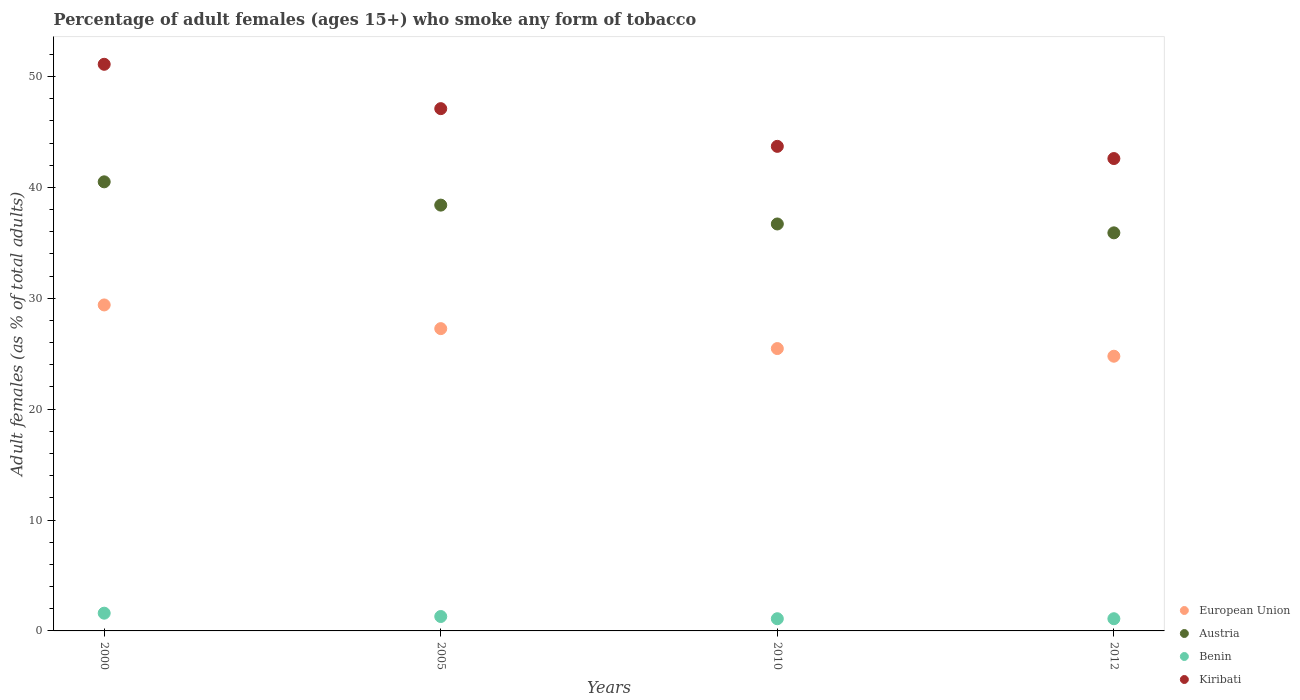How many different coloured dotlines are there?
Give a very brief answer. 4. What is the percentage of adult females who smoke in Austria in 2005?
Your answer should be very brief. 38.4. Across all years, what is the maximum percentage of adult females who smoke in Kiribati?
Your answer should be very brief. 51.1. Across all years, what is the minimum percentage of adult females who smoke in European Union?
Your answer should be very brief. 24.77. In which year was the percentage of adult females who smoke in European Union minimum?
Give a very brief answer. 2012. What is the difference between the percentage of adult females who smoke in Kiribati in 2005 and that in 2010?
Your response must be concise. 3.4. What is the difference between the percentage of adult females who smoke in Kiribati in 2012 and the percentage of adult females who smoke in Austria in 2010?
Your response must be concise. 5.9. What is the average percentage of adult females who smoke in Austria per year?
Make the answer very short. 37.88. In the year 2005, what is the difference between the percentage of adult females who smoke in European Union and percentage of adult females who smoke in Kiribati?
Make the answer very short. -19.84. In how many years, is the percentage of adult females who smoke in European Union greater than 38 %?
Your answer should be very brief. 0. What is the ratio of the percentage of adult females who smoke in Kiribati in 2000 to that in 2005?
Keep it short and to the point. 1.08. Is the difference between the percentage of adult females who smoke in European Union in 2000 and 2005 greater than the difference between the percentage of adult females who smoke in Kiribati in 2000 and 2005?
Offer a very short reply. No. What is the difference between the highest and the second highest percentage of adult females who smoke in European Union?
Your answer should be very brief. 2.14. What is the difference between the highest and the lowest percentage of adult females who smoke in Kiribati?
Keep it short and to the point. 8.5. In how many years, is the percentage of adult females who smoke in Austria greater than the average percentage of adult females who smoke in Austria taken over all years?
Make the answer very short. 2. Is the sum of the percentage of adult females who smoke in Kiribati in 2005 and 2010 greater than the maximum percentage of adult females who smoke in European Union across all years?
Keep it short and to the point. Yes. Is it the case that in every year, the sum of the percentage of adult females who smoke in Kiribati and percentage of adult females who smoke in Austria  is greater than the sum of percentage of adult females who smoke in Benin and percentage of adult females who smoke in European Union?
Your answer should be compact. No. Does the percentage of adult females who smoke in Benin monotonically increase over the years?
Keep it short and to the point. No. Is the percentage of adult females who smoke in Benin strictly greater than the percentage of adult females who smoke in Kiribati over the years?
Give a very brief answer. No. Is the percentage of adult females who smoke in Austria strictly less than the percentage of adult females who smoke in Benin over the years?
Keep it short and to the point. No. How many years are there in the graph?
Offer a very short reply. 4. Are the values on the major ticks of Y-axis written in scientific E-notation?
Ensure brevity in your answer.  No. Does the graph contain any zero values?
Your answer should be compact. No. Where does the legend appear in the graph?
Your answer should be compact. Bottom right. How many legend labels are there?
Provide a succinct answer. 4. What is the title of the graph?
Offer a very short reply. Percentage of adult females (ages 15+) who smoke any form of tobacco. What is the label or title of the Y-axis?
Offer a very short reply. Adult females (as % of total adults). What is the Adult females (as % of total adults) of European Union in 2000?
Your answer should be very brief. 29.4. What is the Adult females (as % of total adults) of Austria in 2000?
Provide a short and direct response. 40.5. What is the Adult females (as % of total adults) in Kiribati in 2000?
Your answer should be very brief. 51.1. What is the Adult females (as % of total adults) in European Union in 2005?
Your answer should be compact. 27.26. What is the Adult females (as % of total adults) of Austria in 2005?
Your answer should be very brief. 38.4. What is the Adult females (as % of total adults) of Benin in 2005?
Offer a terse response. 1.3. What is the Adult females (as % of total adults) in Kiribati in 2005?
Your response must be concise. 47.1. What is the Adult females (as % of total adults) in European Union in 2010?
Keep it short and to the point. 25.46. What is the Adult females (as % of total adults) in Austria in 2010?
Offer a terse response. 36.7. What is the Adult females (as % of total adults) in Benin in 2010?
Keep it short and to the point. 1.1. What is the Adult females (as % of total adults) of Kiribati in 2010?
Your response must be concise. 43.7. What is the Adult females (as % of total adults) in European Union in 2012?
Provide a short and direct response. 24.77. What is the Adult females (as % of total adults) of Austria in 2012?
Provide a short and direct response. 35.9. What is the Adult females (as % of total adults) of Benin in 2012?
Give a very brief answer. 1.1. What is the Adult females (as % of total adults) in Kiribati in 2012?
Provide a succinct answer. 42.6. Across all years, what is the maximum Adult females (as % of total adults) of European Union?
Offer a terse response. 29.4. Across all years, what is the maximum Adult females (as % of total adults) in Austria?
Offer a very short reply. 40.5. Across all years, what is the maximum Adult females (as % of total adults) in Kiribati?
Your answer should be very brief. 51.1. Across all years, what is the minimum Adult females (as % of total adults) in European Union?
Keep it short and to the point. 24.77. Across all years, what is the minimum Adult females (as % of total adults) of Austria?
Offer a very short reply. 35.9. Across all years, what is the minimum Adult females (as % of total adults) of Benin?
Keep it short and to the point. 1.1. Across all years, what is the minimum Adult females (as % of total adults) in Kiribati?
Your answer should be very brief. 42.6. What is the total Adult females (as % of total adults) of European Union in the graph?
Offer a terse response. 106.9. What is the total Adult females (as % of total adults) of Austria in the graph?
Your answer should be compact. 151.5. What is the total Adult females (as % of total adults) of Kiribati in the graph?
Offer a very short reply. 184.5. What is the difference between the Adult females (as % of total adults) of European Union in 2000 and that in 2005?
Give a very brief answer. 2.14. What is the difference between the Adult females (as % of total adults) of Austria in 2000 and that in 2005?
Offer a very short reply. 2.1. What is the difference between the Adult females (as % of total adults) of European Union in 2000 and that in 2010?
Offer a terse response. 3.93. What is the difference between the Adult females (as % of total adults) of Benin in 2000 and that in 2010?
Provide a short and direct response. 0.5. What is the difference between the Adult females (as % of total adults) of European Union in 2000 and that in 2012?
Offer a very short reply. 4.62. What is the difference between the Adult females (as % of total adults) of Austria in 2000 and that in 2012?
Your answer should be compact. 4.6. What is the difference between the Adult females (as % of total adults) of Benin in 2000 and that in 2012?
Your answer should be compact. 0.5. What is the difference between the Adult females (as % of total adults) in Kiribati in 2000 and that in 2012?
Keep it short and to the point. 8.5. What is the difference between the Adult females (as % of total adults) of European Union in 2005 and that in 2010?
Ensure brevity in your answer.  1.8. What is the difference between the Adult females (as % of total adults) of Kiribati in 2005 and that in 2010?
Your answer should be compact. 3.4. What is the difference between the Adult females (as % of total adults) of European Union in 2005 and that in 2012?
Offer a very short reply. 2.49. What is the difference between the Adult females (as % of total adults) in Austria in 2005 and that in 2012?
Make the answer very short. 2.5. What is the difference between the Adult females (as % of total adults) of Kiribati in 2005 and that in 2012?
Your response must be concise. 4.5. What is the difference between the Adult females (as % of total adults) of European Union in 2010 and that in 2012?
Give a very brief answer. 0.69. What is the difference between the Adult females (as % of total adults) of Austria in 2010 and that in 2012?
Offer a terse response. 0.8. What is the difference between the Adult females (as % of total adults) of Benin in 2010 and that in 2012?
Offer a very short reply. 0. What is the difference between the Adult females (as % of total adults) in European Union in 2000 and the Adult females (as % of total adults) in Austria in 2005?
Provide a succinct answer. -9. What is the difference between the Adult females (as % of total adults) of European Union in 2000 and the Adult females (as % of total adults) of Benin in 2005?
Offer a terse response. 28.1. What is the difference between the Adult females (as % of total adults) in European Union in 2000 and the Adult females (as % of total adults) in Kiribati in 2005?
Provide a short and direct response. -17.7. What is the difference between the Adult females (as % of total adults) in Austria in 2000 and the Adult females (as % of total adults) in Benin in 2005?
Provide a succinct answer. 39.2. What is the difference between the Adult females (as % of total adults) in Austria in 2000 and the Adult females (as % of total adults) in Kiribati in 2005?
Provide a succinct answer. -6.6. What is the difference between the Adult females (as % of total adults) of Benin in 2000 and the Adult females (as % of total adults) of Kiribati in 2005?
Offer a very short reply. -45.5. What is the difference between the Adult females (as % of total adults) in European Union in 2000 and the Adult females (as % of total adults) in Austria in 2010?
Offer a very short reply. -7.3. What is the difference between the Adult females (as % of total adults) in European Union in 2000 and the Adult females (as % of total adults) in Benin in 2010?
Your answer should be compact. 28.3. What is the difference between the Adult females (as % of total adults) in European Union in 2000 and the Adult females (as % of total adults) in Kiribati in 2010?
Offer a very short reply. -14.3. What is the difference between the Adult females (as % of total adults) in Austria in 2000 and the Adult females (as % of total adults) in Benin in 2010?
Your answer should be compact. 39.4. What is the difference between the Adult females (as % of total adults) in Austria in 2000 and the Adult females (as % of total adults) in Kiribati in 2010?
Ensure brevity in your answer.  -3.2. What is the difference between the Adult females (as % of total adults) in Benin in 2000 and the Adult females (as % of total adults) in Kiribati in 2010?
Offer a terse response. -42.1. What is the difference between the Adult females (as % of total adults) of European Union in 2000 and the Adult females (as % of total adults) of Austria in 2012?
Ensure brevity in your answer.  -6.5. What is the difference between the Adult females (as % of total adults) in European Union in 2000 and the Adult females (as % of total adults) in Benin in 2012?
Provide a succinct answer. 28.3. What is the difference between the Adult females (as % of total adults) of European Union in 2000 and the Adult females (as % of total adults) of Kiribati in 2012?
Your response must be concise. -13.2. What is the difference between the Adult females (as % of total adults) of Austria in 2000 and the Adult females (as % of total adults) of Benin in 2012?
Keep it short and to the point. 39.4. What is the difference between the Adult females (as % of total adults) in Austria in 2000 and the Adult females (as % of total adults) in Kiribati in 2012?
Your answer should be very brief. -2.1. What is the difference between the Adult females (as % of total adults) of Benin in 2000 and the Adult females (as % of total adults) of Kiribati in 2012?
Your answer should be very brief. -41. What is the difference between the Adult females (as % of total adults) of European Union in 2005 and the Adult females (as % of total adults) of Austria in 2010?
Ensure brevity in your answer.  -9.44. What is the difference between the Adult females (as % of total adults) of European Union in 2005 and the Adult females (as % of total adults) of Benin in 2010?
Your answer should be very brief. 26.16. What is the difference between the Adult females (as % of total adults) of European Union in 2005 and the Adult females (as % of total adults) of Kiribati in 2010?
Offer a terse response. -16.44. What is the difference between the Adult females (as % of total adults) in Austria in 2005 and the Adult females (as % of total adults) in Benin in 2010?
Provide a short and direct response. 37.3. What is the difference between the Adult females (as % of total adults) of Benin in 2005 and the Adult females (as % of total adults) of Kiribati in 2010?
Ensure brevity in your answer.  -42.4. What is the difference between the Adult females (as % of total adults) of European Union in 2005 and the Adult females (as % of total adults) of Austria in 2012?
Provide a short and direct response. -8.64. What is the difference between the Adult females (as % of total adults) in European Union in 2005 and the Adult females (as % of total adults) in Benin in 2012?
Ensure brevity in your answer.  26.16. What is the difference between the Adult females (as % of total adults) of European Union in 2005 and the Adult females (as % of total adults) of Kiribati in 2012?
Provide a short and direct response. -15.34. What is the difference between the Adult females (as % of total adults) of Austria in 2005 and the Adult females (as % of total adults) of Benin in 2012?
Your answer should be very brief. 37.3. What is the difference between the Adult females (as % of total adults) in Benin in 2005 and the Adult females (as % of total adults) in Kiribati in 2012?
Give a very brief answer. -41.3. What is the difference between the Adult females (as % of total adults) in European Union in 2010 and the Adult females (as % of total adults) in Austria in 2012?
Ensure brevity in your answer.  -10.44. What is the difference between the Adult females (as % of total adults) in European Union in 2010 and the Adult females (as % of total adults) in Benin in 2012?
Provide a short and direct response. 24.36. What is the difference between the Adult females (as % of total adults) of European Union in 2010 and the Adult females (as % of total adults) of Kiribati in 2012?
Provide a succinct answer. -17.14. What is the difference between the Adult females (as % of total adults) in Austria in 2010 and the Adult females (as % of total adults) in Benin in 2012?
Your response must be concise. 35.6. What is the difference between the Adult females (as % of total adults) in Austria in 2010 and the Adult females (as % of total adults) in Kiribati in 2012?
Provide a short and direct response. -5.9. What is the difference between the Adult females (as % of total adults) in Benin in 2010 and the Adult females (as % of total adults) in Kiribati in 2012?
Your answer should be compact. -41.5. What is the average Adult females (as % of total adults) of European Union per year?
Your answer should be very brief. 26.72. What is the average Adult females (as % of total adults) in Austria per year?
Offer a terse response. 37.88. What is the average Adult females (as % of total adults) in Benin per year?
Ensure brevity in your answer.  1.27. What is the average Adult females (as % of total adults) in Kiribati per year?
Keep it short and to the point. 46.12. In the year 2000, what is the difference between the Adult females (as % of total adults) in European Union and Adult females (as % of total adults) in Austria?
Make the answer very short. -11.1. In the year 2000, what is the difference between the Adult females (as % of total adults) in European Union and Adult females (as % of total adults) in Benin?
Offer a terse response. 27.8. In the year 2000, what is the difference between the Adult females (as % of total adults) of European Union and Adult females (as % of total adults) of Kiribati?
Your answer should be very brief. -21.7. In the year 2000, what is the difference between the Adult females (as % of total adults) in Austria and Adult females (as % of total adults) in Benin?
Your response must be concise. 38.9. In the year 2000, what is the difference between the Adult females (as % of total adults) in Austria and Adult females (as % of total adults) in Kiribati?
Your response must be concise. -10.6. In the year 2000, what is the difference between the Adult females (as % of total adults) in Benin and Adult females (as % of total adults) in Kiribati?
Your answer should be compact. -49.5. In the year 2005, what is the difference between the Adult females (as % of total adults) of European Union and Adult females (as % of total adults) of Austria?
Ensure brevity in your answer.  -11.14. In the year 2005, what is the difference between the Adult females (as % of total adults) in European Union and Adult females (as % of total adults) in Benin?
Your answer should be compact. 25.96. In the year 2005, what is the difference between the Adult females (as % of total adults) of European Union and Adult females (as % of total adults) of Kiribati?
Offer a very short reply. -19.84. In the year 2005, what is the difference between the Adult females (as % of total adults) in Austria and Adult females (as % of total adults) in Benin?
Your response must be concise. 37.1. In the year 2005, what is the difference between the Adult females (as % of total adults) in Austria and Adult females (as % of total adults) in Kiribati?
Your response must be concise. -8.7. In the year 2005, what is the difference between the Adult females (as % of total adults) in Benin and Adult females (as % of total adults) in Kiribati?
Ensure brevity in your answer.  -45.8. In the year 2010, what is the difference between the Adult females (as % of total adults) of European Union and Adult females (as % of total adults) of Austria?
Offer a terse response. -11.24. In the year 2010, what is the difference between the Adult females (as % of total adults) of European Union and Adult females (as % of total adults) of Benin?
Give a very brief answer. 24.36. In the year 2010, what is the difference between the Adult females (as % of total adults) of European Union and Adult females (as % of total adults) of Kiribati?
Provide a succinct answer. -18.24. In the year 2010, what is the difference between the Adult females (as % of total adults) in Austria and Adult females (as % of total adults) in Benin?
Make the answer very short. 35.6. In the year 2010, what is the difference between the Adult females (as % of total adults) of Austria and Adult females (as % of total adults) of Kiribati?
Keep it short and to the point. -7. In the year 2010, what is the difference between the Adult females (as % of total adults) in Benin and Adult females (as % of total adults) in Kiribati?
Provide a succinct answer. -42.6. In the year 2012, what is the difference between the Adult females (as % of total adults) in European Union and Adult females (as % of total adults) in Austria?
Your answer should be compact. -11.13. In the year 2012, what is the difference between the Adult females (as % of total adults) of European Union and Adult females (as % of total adults) of Benin?
Your answer should be very brief. 23.67. In the year 2012, what is the difference between the Adult females (as % of total adults) of European Union and Adult females (as % of total adults) of Kiribati?
Your answer should be very brief. -17.83. In the year 2012, what is the difference between the Adult females (as % of total adults) of Austria and Adult females (as % of total adults) of Benin?
Offer a terse response. 34.8. In the year 2012, what is the difference between the Adult females (as % of total adults) of Austria and Adult females (as % of total adults) of Kiribati?
Ensure brevity in your answer.  -6.7. In the year 2012, what is the difference between the Adult females (as % of total adults) of Benin and Adult females (as % of total adults) of Kiribati?
Offer a very short reply. -41.5. What is the ratio of the Adult females (as % of total adults) in European Union in 2000 to that in 2005?
Offer a terse response. 1.08. What is the ratio of the Adult females (as % of total adults) of Austria in 2000 to that in 2005?
Give a very brief answer. 1.05. What is the ratio of the Adult females (as % of total adults) of Benin in 2000 to that in 2005?
Give a very brief answer. 1.23. What is the ratio of the Adult females (as % of total adults) in Kiribati in 2000 to that in 2005?
Your answer should be compact. 1.08. What is the ratio of the Adult females (as % of total adults) of European Union in 2000 to that in 2010?
Provide a short and direct response. 1.15. What is the ratio of the Adult females (as % of total adults) of Austria in 2000 to that in 2010?
Your answer should be compact. 1.1. What is the ratio of the Adult females (as % of total adults) of Benin in 2000 to that in 2010?
Your answer should be compact. 1.45. What is the ratio of the Adult females (as % of total adults) in Kiribati in 2000 to that in 2010?
Provide a short and direct response. 1.17. What is the ratio of the Adult females (as % of total adults) of European Union in 2000 to that in 2012?
Offer a very short reply. 1.19. What is the ratio of the Adult females (as % of total adults) of Austria in 2000 to that in 2012?
Your answer should be very brief. 1.13. What is the ratio of the Adult females (as % of total adults) in Benin in 2000 to that in 2012?
Your answer should be very brief. 1.45. What is the ratio of the Adult females (as % of total adults) of Kiribati in 2000 to that in 2012?
Keep it short and to the point. 1.2. What is the ratio of the Adult females (as % of total adults) of European Union in 2005 to that in 2010?
Provide a succinct answer. 1.07. What is the ratio of the Adult females (as % of total adults) in Austria in 2005 to that in 2010?
Make the answer very short. 1.05. What is the ratio of the Adult females (as % of total adults) in Benin in 2005 to that in 2010?
Provide a short and direct response. 1.18. What is the ratio of the Adult females (as % of total adults) of Kiribati in 2005 to that in 2010?
Your response must be concise. 1.08. What is the ratio of the Adult females (as % of total adults) in European Union in 2005 to that in 2012?
Offer a terse response. 1.1. What is the ratio of the Adult females (as % of total adults) of Austria in 2005 to that in 2012?
Offer a terse response. 1.07. What is the ratio of the Adult females (as % of total adults) in Benin in 2005 to that in 2012?
Provide a succinct answer. 1.18. What is the ratio of the Adult females (as % of total adults) in Kiribati in 2005 to that in 2012?
Offer a terse response. 1.11. What is the ratio of the Adult females (as % of total adults) in European Union in 2010 to that in 2012?
Ensure brevity in your answer.  1.03. What is the ratio of the Adult females (as % of total adults) in Austria in 2010 to that in 2012?
Offer a terse response. 1.02. What is the ratio of the Adult females (as % of total adults) in Kiribati in 2010 to that in 2012?
Keep it short and to the point. 1.03. What is the difference between the highest and the second highest Adult females (as % of total adults) of European Union?
Your response must be concise. 2.14. What is the difference between the highest and the second highest Adult females (as % of total adults) of Benin?
Your answer should be compact. 0.3. What is the difference between the highest and the lowest Adult females (as % of total adults) of European Union?
Provide a succinct answer. 4.62. What is the difference between the highest and the lowest Adult females (as % of total adults) in Benin?
Ensure brevity in your answer.  0.5. 